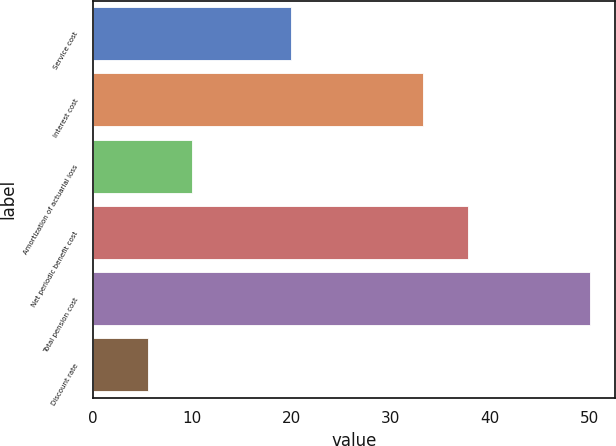Convert chart. <chart><loc_0><loc_0><loc_500><loc_500><bar_chart><fcel>Service cost<fcel>Interest cost<fcel>Amortization of actuarial loss<fcel>Net periodic benefit cost<fcel>Total pension cost<fcel>Discount rate<nl><fcel>20<fcel>33.3<fcel>9.99<fcel>37.76<fcel>50.1<fcel>5.53<nl></chart> 